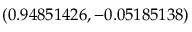<formula> <loc_0><loc_0><loc_500><loc_500>( 0 . 9 4 8 5 1 4 2 6 , - 0 . 0 5 1 8 5 1 3 8 )</formula> 